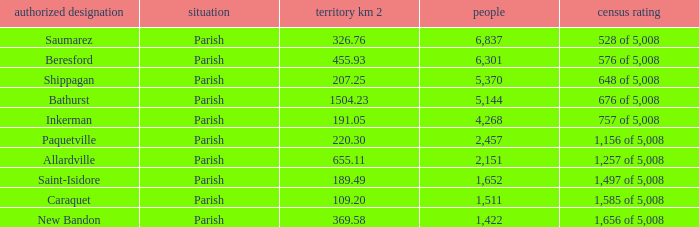What is the Area of the Allardville Parish with a Population smaller than 2,151? None. 